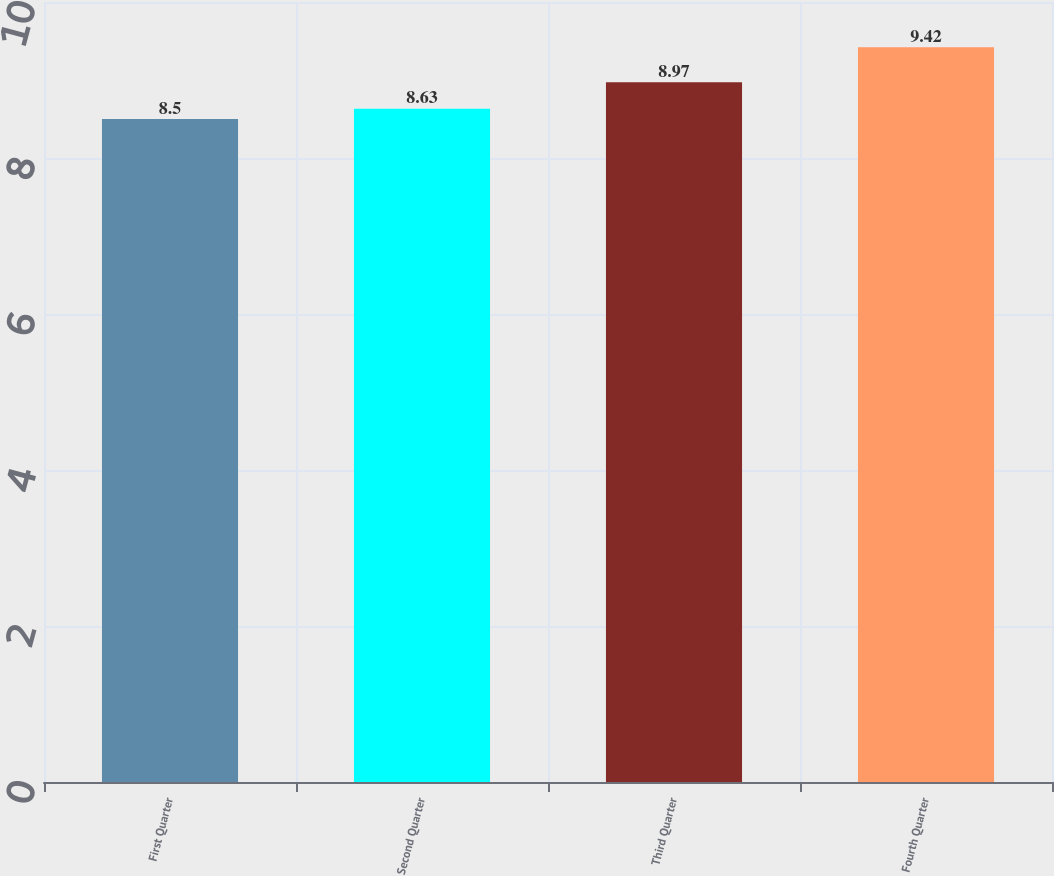<chart> <loc_0><loc_0><loc_500><loc_500><bar_chart><fcel>First Quarter<fcel>Second Quarter<fcel>Third Quarter<fcel>Fourth Quarter<nl><fcel>8.5<fcel>8.63<fcel>8.97<fcel>9.42<nl></chart> 